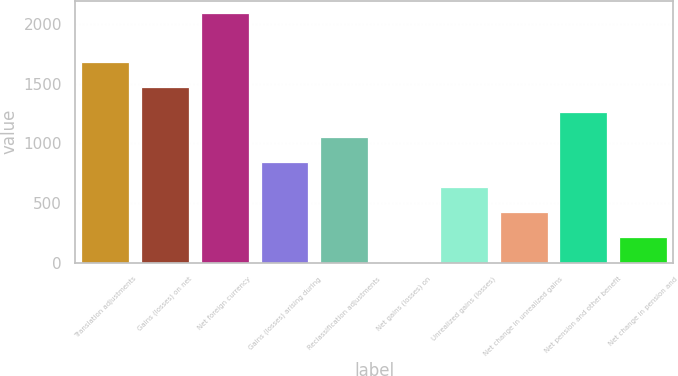Convert chart. <chart><loc_0><loc_0><loc_500><loc_500><bar_chart><fcel>Translation adjustments<fcel>Gains (losses) on net<fcel>Net foreign currency<fcel>Gains (losses) arising during<fcel>Reclassification adjustments<fcel>Net gains (losses) on<fcel>Unrealized gains (losses)<fcel>Net change in unrealized gains<fcel>Net pension and other benefit<fcel>Net change in pension and<nl><fcel>1681.4<fcel>1472.1<fcel>2088<fcel>844.2<fcel>1053.5<fcel>7<fcel>634.9<fcel>425.6<fcel>1262.8<fcel>216.3<nl></chart> 